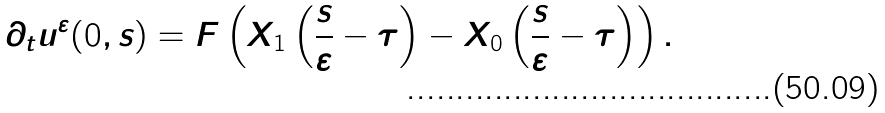<formula> <loc_0><loc_0><loc_500><loc_500>\partial _ { t } u ^ { \varepsilon } ( 0 , s ) = F \left ( X _ { 1 } \left ( \frac { s } { \varepsilon } - \tau \right ) - X _ { 0 } \left ( \frac { s } { \varepsilon } - \tau \right ) \right ) .</formula> 